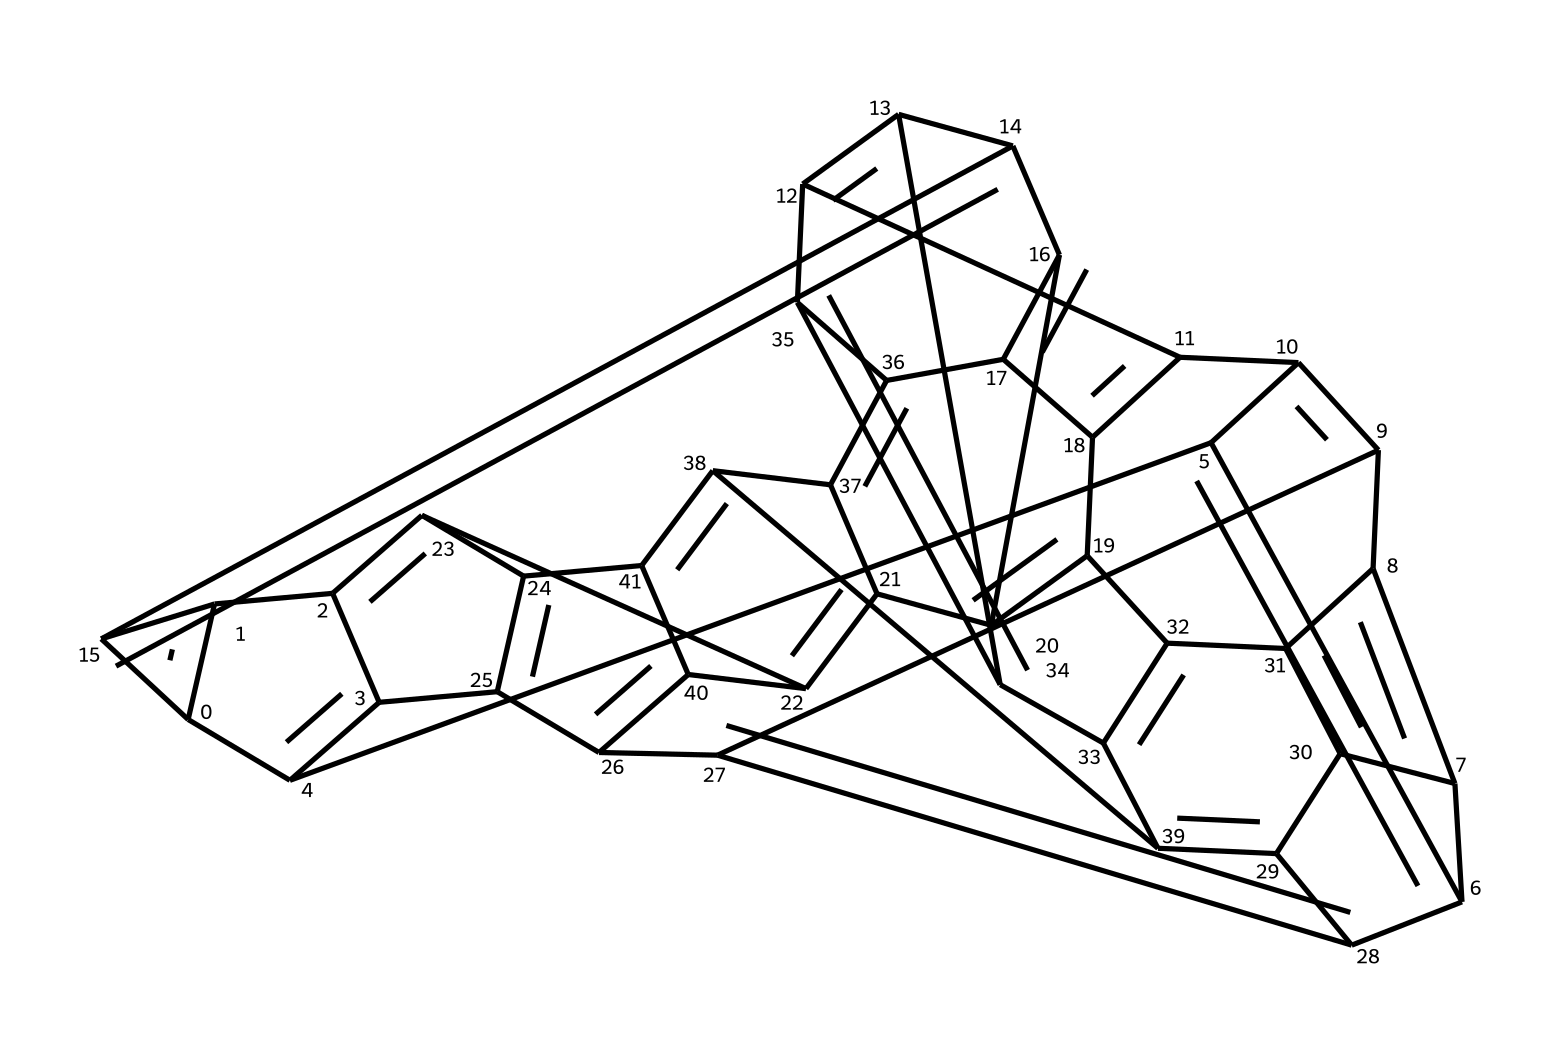What is the basic name of this chemical? The chemical represented by the SMILES notation is Fullerene C60, which is a spherical molecule composed of 60 carbon atoms arranged in a pattern that resembles a soccer ball.
Answer: Fullerene C60 How many carbon atoms are present in this structure? By analyzing the SMILES representation, we can identify that there are a total of 60 carbon atoms. This is characteristic of the C60 fullerene structure.
Answer: 60 What type of hybridization do the carbon atoms in this molecule exhibit? The carbon atoms in C60 are trigonal planar, exhibiting sp² hybridization due to their bonding arrangement forming hexagons and pentagons.
Answer: sp² How many double bonds are present in this molecule? Upon examining the structure, there are 12 double bonds located between various carbon atoms throughout the C60 framework.
Answer: 12 What geometric shape does Fullerene C60 resemble? Fullerene C60 has a geometric structure that resembles a truncated icosahedron, which is similar to a soccer ball with its arrangement of faces made up of hexagons and pentagons.
Answer: truncated icosahedron How does the structure of C60 relate to nodes in a network? The structure of C60 can be compared to nodes in a network, where each carbon atom acts as a node connected by edges (bonds), illustrating how information can be optimized for routing through interconnected nodes.
Answer: nodes and edges What is a unique property of fullerides like C60 that distinguishes them from other carbon allotropes? Fullerides such as C60 exhibit unique properties such as superconductivity and the ability to encapsulate other atoms or molecules within their hollow structure, setting them apart from other forms of carbon.
Answer: superconductivity 